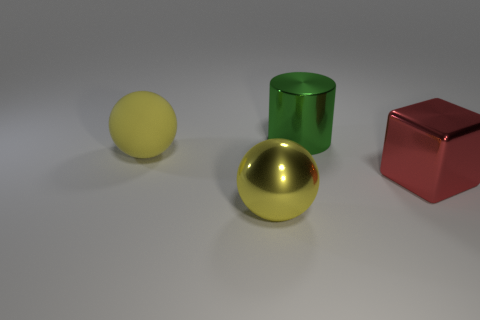Add 1 small cyan things. How many objects exist? 5 Subtract all cubes. How many objects are left? 3 Add 4 yellow metal things. How many yellow metal things are left? 5 Add 3 green metal cylinders. How many green metal cylinders exist? 4 Subtract 0 gray cylinders. How many objects are left? 4 Subtract all big green shiny objects. Subtract all green cylinders. How many objects are left? 2 